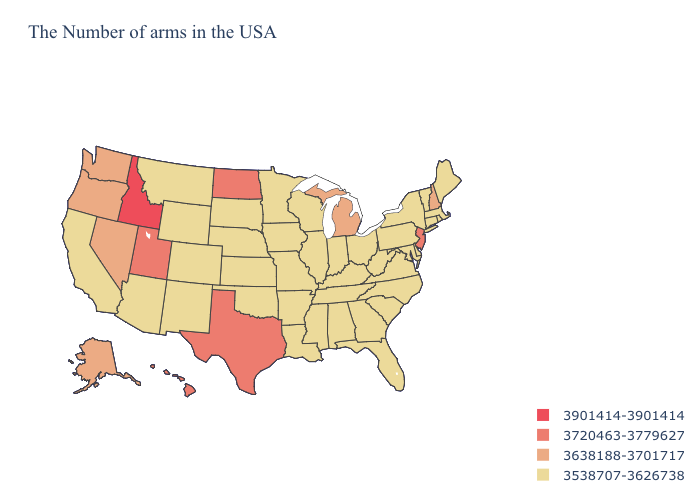Name the states that have a value in the range 3901414-3901414?
Give a very brief answer. Idaho. Which states hav the highest value in the Northeast?
Answer briefly. New Jersey. Does the first symbol in the legend represent the smallest category?
Be succinct. No. Name the states that have a value in the range 3901414-3901414?
Answer briefly. Idaho. Which states have the lowest value in the USA?
Write a very short answer. Maine, Massachusetts, Rhode Island, Vermont, Connecticut, New York, Delaware, Maryland, Pennsylvania, Virginia, North Carolina, South Carolina, West Virginia, Ohio, Florida, Georgia, Kentucky, Indiana, Alabama, Tennessee, Wisconsin, Illinois, Mississippi, Louisiana, Missouri, Arkansas, Minnesota, Iowa, Kansas, Nebraska, Oklahoma, South Dakota, Wyoming, Colorado, New Mexico, Montana, Arizona, California. What is the lowest value in the USA?
Keep it brief. 3538707-3626738. Name the states that have a value in the range 3901414-3901414?
Be succinct. Idaho. What is the value of Idaho?
Concise answer only. 3901414-3901414. How many symbols are there in the legend?
Be succinct. 4. What is the value of Montana?
Quick response, please. 3538707-3626738. What is the value of Massachusetts?
Give a very brief answer. 3538707-3626738. Does Massachusetts have the same value as New Jersey?
Short answer required. No. Does Alabama have a lower value than Alaska?
Short answer required. Yes. Does New Jersey have the highest value in the Northeast?
Concise answer only. Yes. 